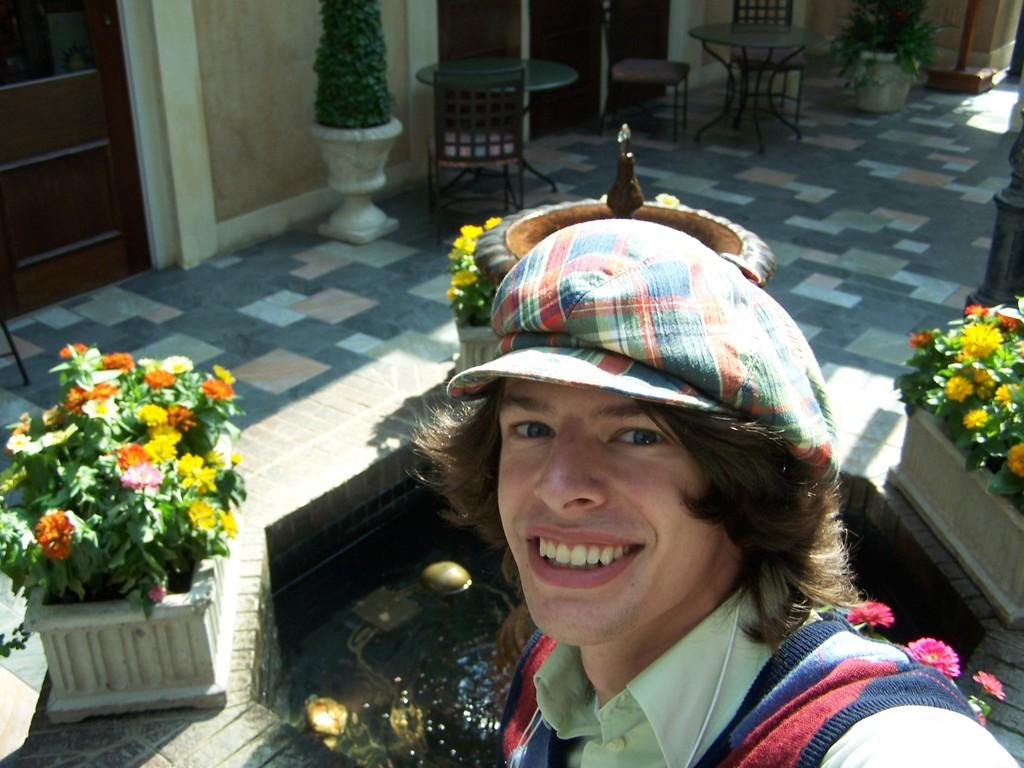What is the main subject in the image? There is a person standing in the image. What is the background element in the image? There is a fountain in the image. What type of vegetation can be seen in the image? Flowers are present in the image. What type of furniture is visible in the image? There are tables and chairs visible in the image. What type of cord is being used to power the stage in the image? There is no stage or cord present in the image; it features a person, a fountain, flowers, tables, and chairs. 